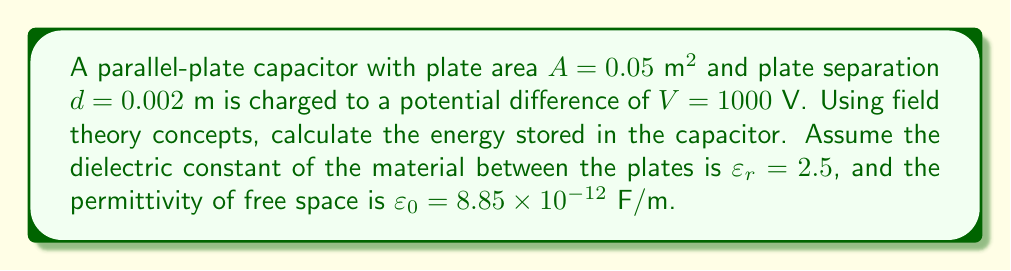Can you answer this question? 1) First, we need to calculate the capacitance of the parallel-plate capacitor:
   $$C = \frac{\varepsilon_0 \varepsilon_r A}{d}$$

2) Substituting the given values:
   $$C = \frac{(8.85 \times 10^{-12})(2.5)(0.05)}{0.002} = 5.53125 \times 10^{-9} \text{ F}$$

3) Now, we can calculate the charge on the capacitor:
   $$Q = CV = (5.53125 \times 10^{-9})(1000) = 5.53125 \times 10^{-6} \text{ C}$$

4) The electric field strength between the plates is:
   $$E = \frac{V}{d} = \frac{1000}{0.002} = 5 \times 10^5 \text{ V/m}$$

5) The energy density in the electric field is given by:
   $$u = \frac{1}{2}\varepsilon_0 \varepsilon_r E^2$$

6) Substituting the values:
   $$u = \frac{1}{2}(8.85 \times 10^{-12})(2.5)(5 \times 10^5)^2 = 2.765625 \times 10^3 \text{ J/m}^3$$

7) The total energy stored is the energy density multiplied by the volume between the plates:
   $$U = u(Ad) = (2.765625 \times 10^3)(0.05 \times 0.002) = 2.765625 \times 10^{-3} \text{ J}$$

8) We can verify this result using the familiar formula for energy stored in a capacitor:
   $$U = \frac{1}{2}CV^2 = \frac{1}{2}(5.53125 \times 10^{-9})(1000)^2 = 2.765625 \times 10^{-3} \text{ J}$$
Answer: $2.765625 \times 10^{-3} \text{ J}$ 